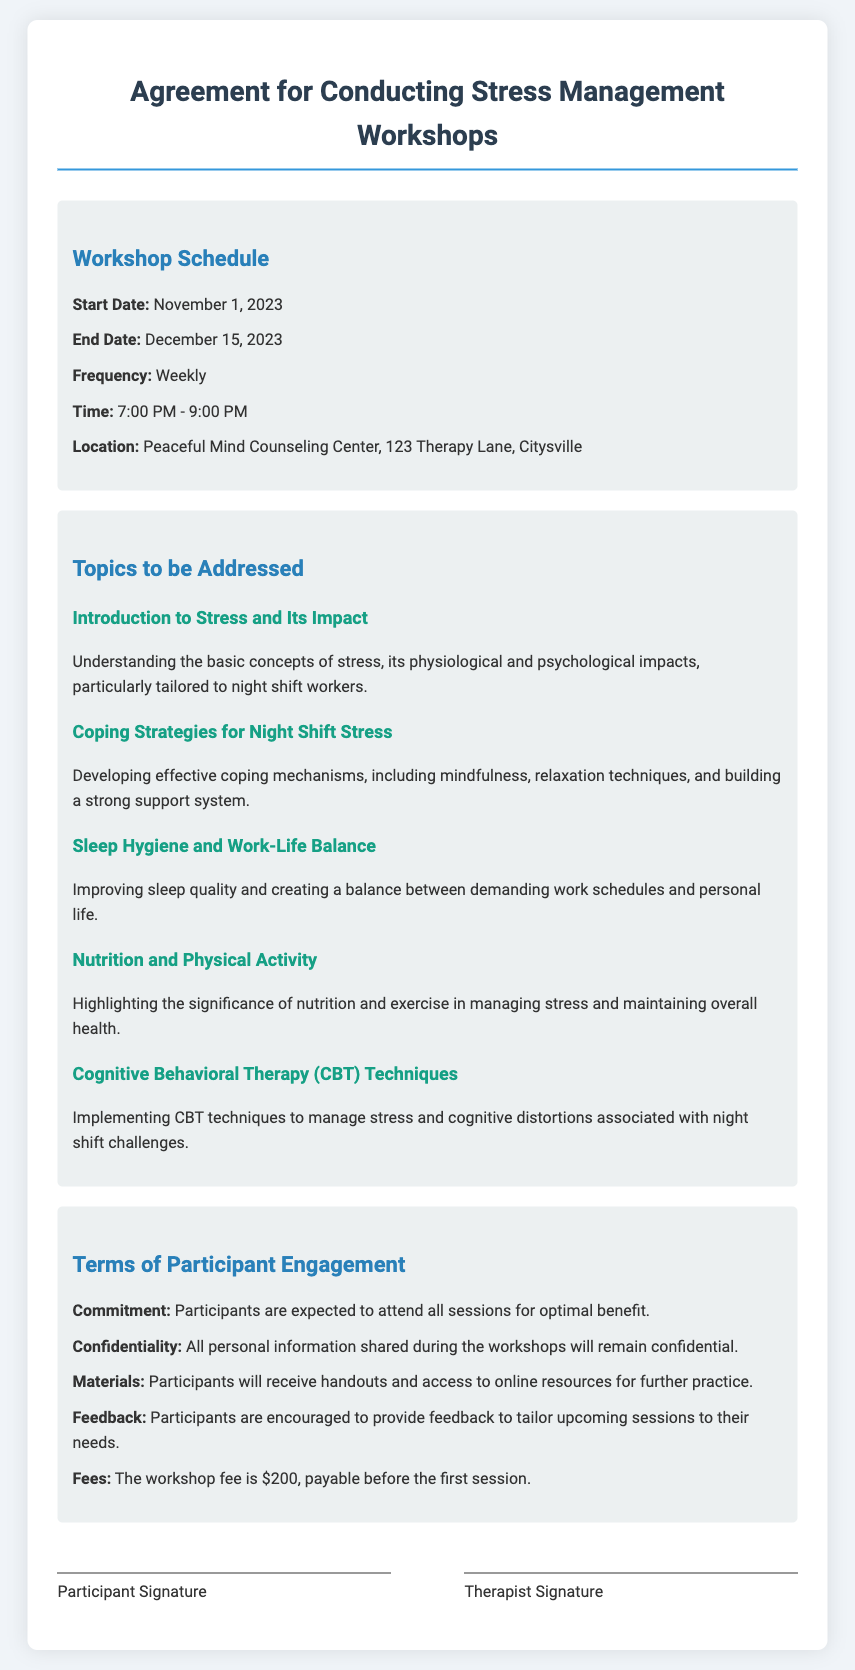what is the start date of the workshop? The start date is explicitly mentioned in the workshop schedule section of the document.
Answer: November 1, 2023 what is the end date of the workshop? The end date is clearly stated in the workshop schedule section.
Answer: December 15, 2023 how often will the workshops be held? The frequency of the workshops is noted in the schedule section of the document.
Answer: Weekly what time do the workshops start? The time is specified in the workshop schedule.
Answer: 7:00 PM what is one topic to be addressed in the workshops? The topics to be addressed are listed in their respective section, highlighting the focus of the workshops.
Answer: Coping Strategies for Night Shift Stress what is the fee for participation in the workshop? The fee is outlined in the terms of participant engagement section.
Answer: $200 what is expected from participants regarding attendance? The commitment expected from participants is described in the terms of engagement section.
Answer: Attend all sessions what will participants receive during the workshops? The materials provided to participants are detailed in the terms section.
Answer: Handouts and access to online resources what is the purpose of the feedback from participants? The reasoning for feedback is mentioned in the terms of participant engagement, indicating its role in session tailoring.
Answer: Tailor upcoming sessions to their needs 